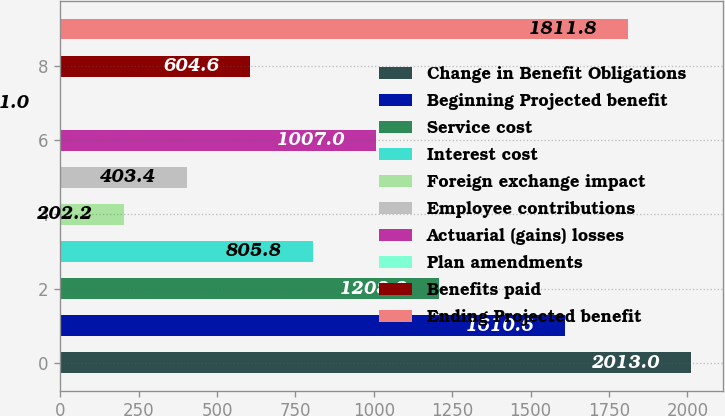Convert chart to OTSL. <chart><loc_0><loc_0><loc_500><loc_500><bar_chart><fcel>Change in Benefit Obligations<fcel>Beginning Projected benefit<fcel>Service cost<fcel>Interest cost<fcel>Foreign exchange impact<fcel>Employee contributions<fcel>Actuarial (gains) losses<fcel>Plan amendments<fcel>Benefits paid<fcel>Ending Projected benefit<nl><fcel>2013<fcel>1610.6<fcel>1208.2<fcel>805.8<fcel>202.2<fcel>403.4<fcel>1007<fcel>1<fcel>604.6<fcel>1811.8<nl></chart> 